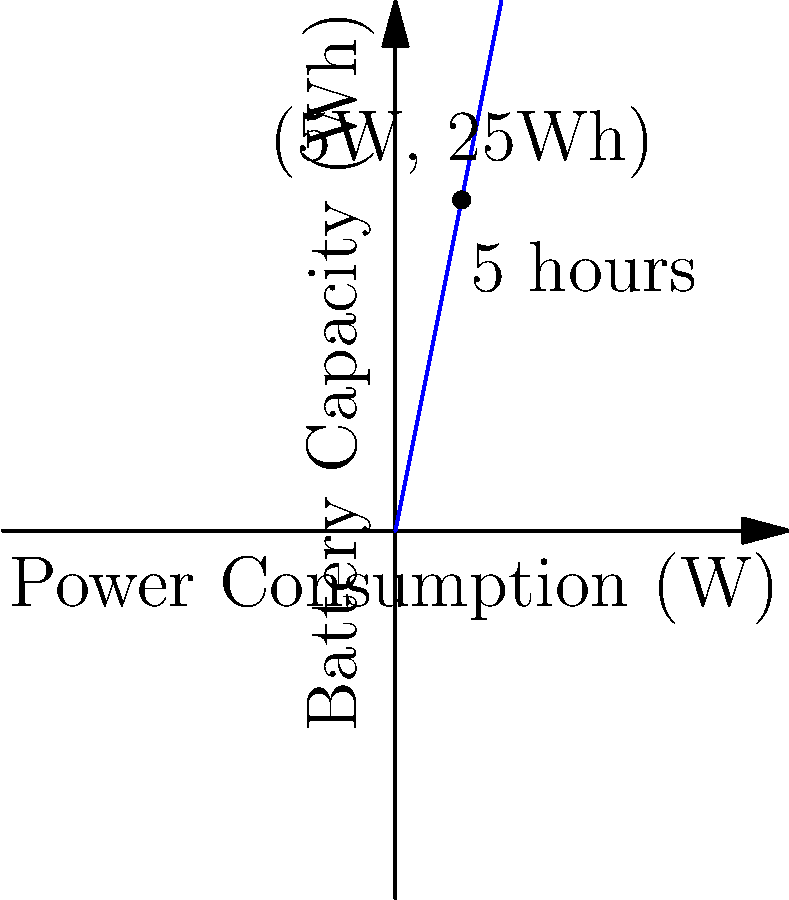As a sports analyst, you need a portable device for game analysis during Red Sox and Bruins matches. The device consumes 5W of power. How many watt-hours (Wh) of battery capacity do you need for the device to last through a 5-hour game? To calculate the required battery capacity, we need to follow these steps:

1. Identify the given information:
   - Power consumption: $P = 5$ W
   - Desired operation time: $t = 5$ hours

2. Use the formula for energy (in watt-hours):
   $E = P \times t$

   Where:
   $E$ = Energy (battery capacity) in watt-hours (Wh)
   $P$ = Power consumption in watts (W)
   $t$ = Time in hours (h)

3. Plug in the values:
   $E = 5 \text{ W} \times 5 \text{ h}$

4. Calculate the result:
   $E = 25 \text{ Wh}$

Therefore, you need a battery with a capacity of 25 watt-hours to power the device for a 5-hour game.
Answer: 25 Wh 